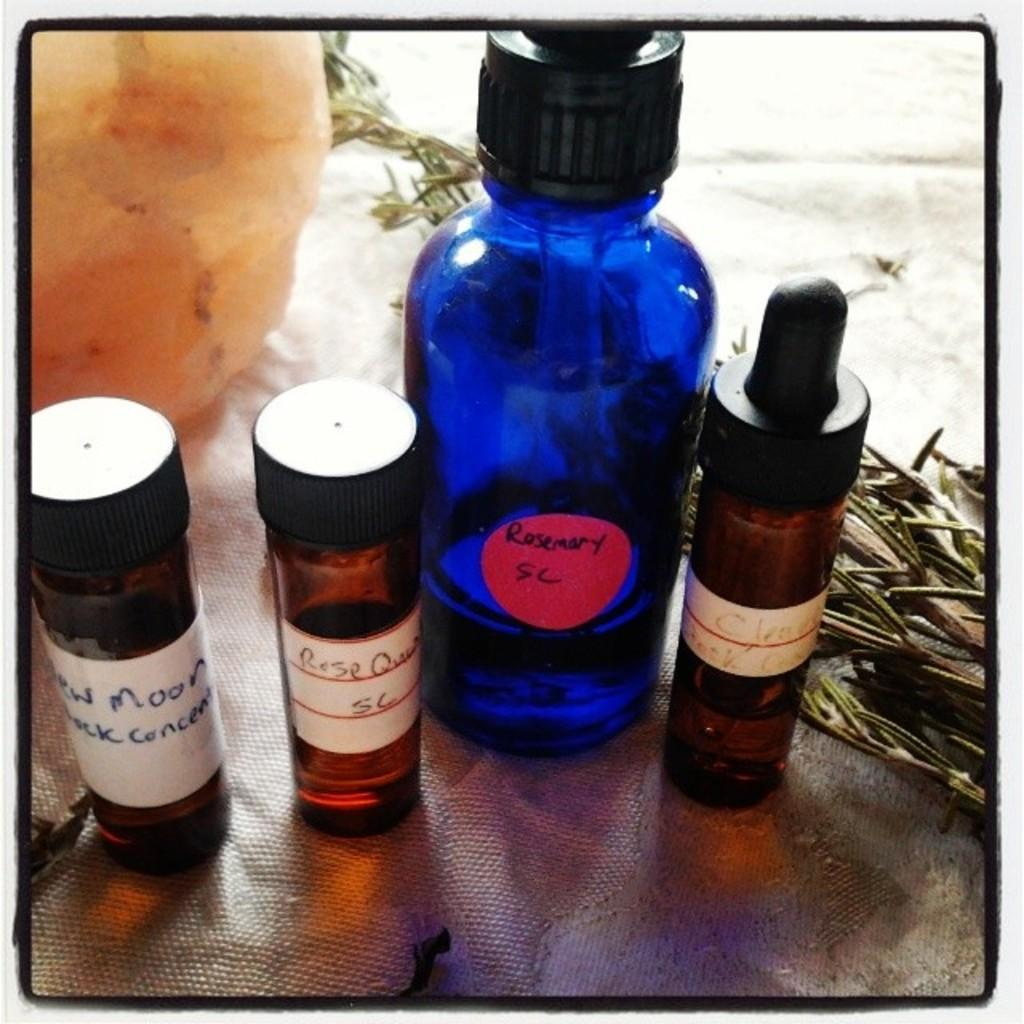Provide a one-sentence caption for the provided image. Blue bottle saying Rosemary in between some other bottles. 